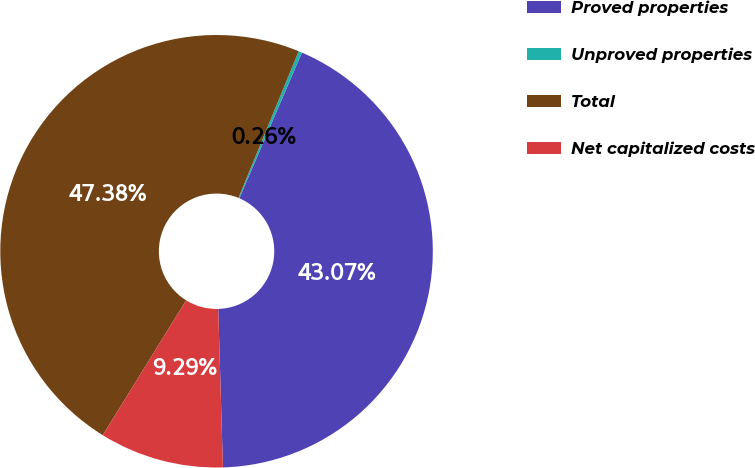<chart> <loc_0><loc_0><loc_500><loc_500><pie_chart><fcel>Proved properties<fcel>Unproved properties<fcel>Total<fcel>Net capitalized costs<nl><fcel>43.07%<fcel>0.26%<fcel>47.38%<fcel>9.29%<nl></chart> 